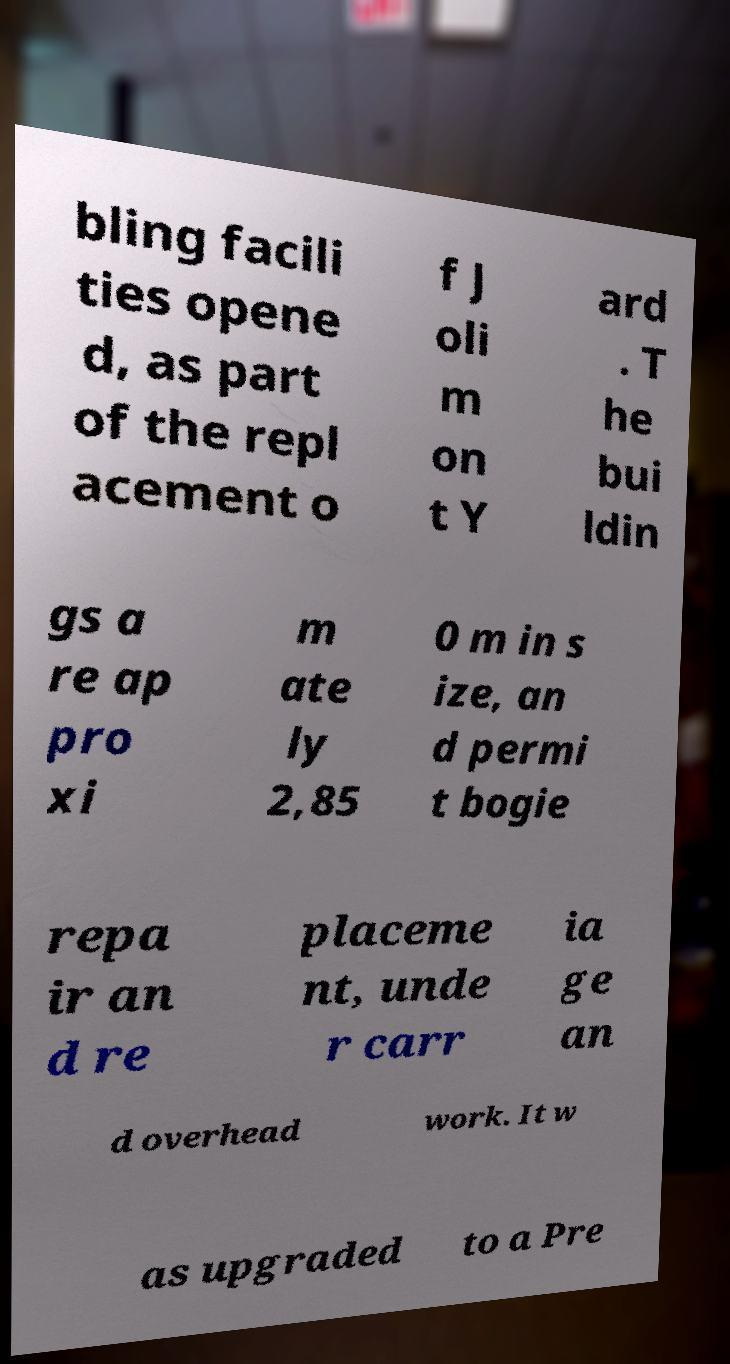Could you assist in decoding the text presented in this image and type it out clearly? bling facili ties opene d, as part of the repl acement o f J oli m on t Y ard . T he bui ldin gs a re ap pro xi m ate ly 2,85 0 m in s ize, an d permi t bogie repa ir an d re placeme nt, unde r carr ia ge an d overhead work. It w as upgraded to a Pre 